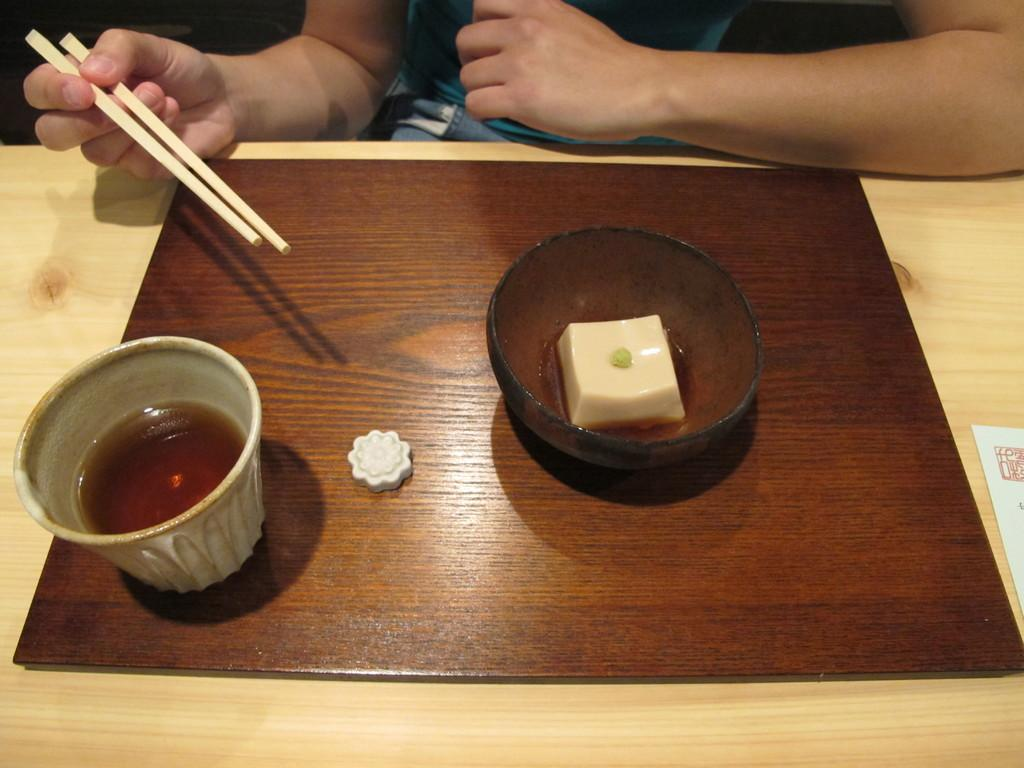Who is present in the image? There is a person in the image. What is the person holding in the image? The person is holding chopsticks. What can be seen on the table in the image? There is a table in the image, and there are utensils on the table. What is the plate made of that holds the food? The plate made of wood holds the food. What type of ice can be seen melting on the person's nose in the image? There is no ice present on the person's nose in the image. What is inside the jar that is visible on the table in the image? There is no jar visible on the table in the image. 